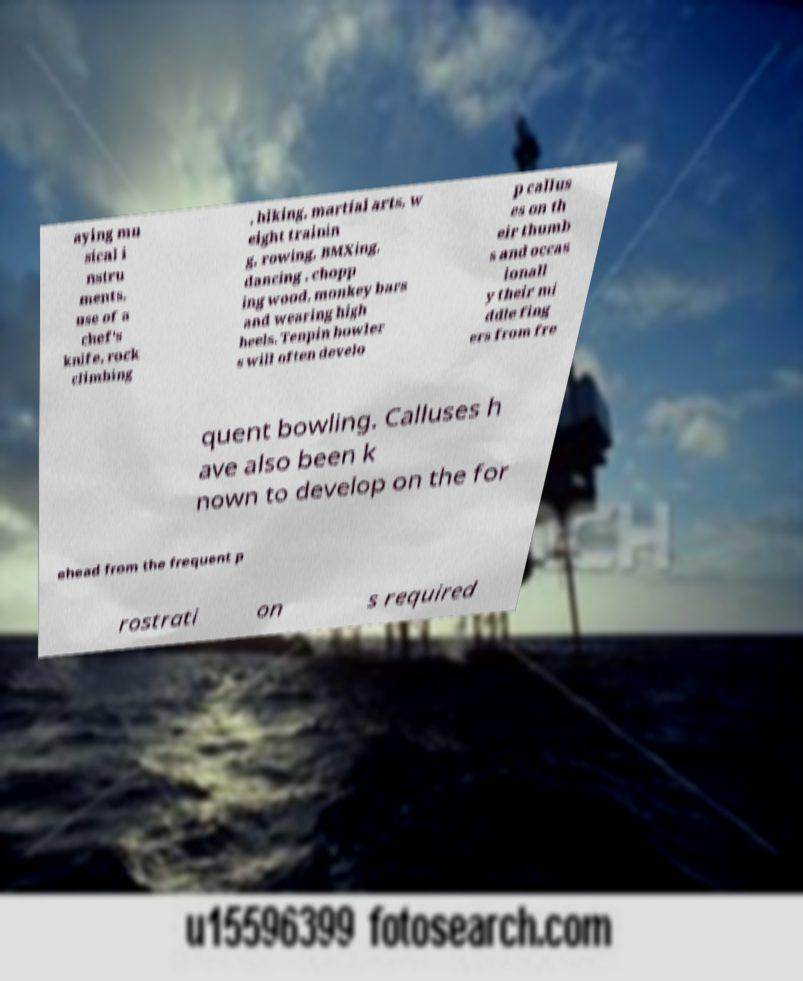Could you extract and type out the text from this image? aying mu sical i nstru ments, use of a chef's knife, rock climbing , hiking, martial arts, w eight trainin g, rowing, BMXing, dancing , chopp ing wood, monkey bars and wearing high heels. Tenpin bowler s will often develo p callus es on th eir thumb s and occas ionall y their mi ddle fing ers from fre quent bowling. Calluses h ave also been k nown to develop on the for ehead from the frequent p rostrati on s required 